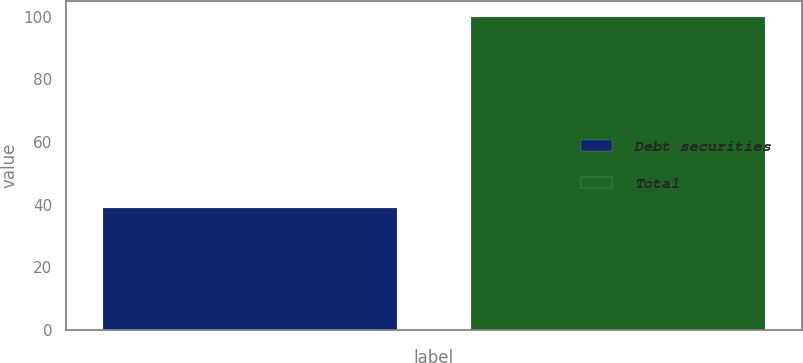Convert chart to OTSL. <chart><loc_0><loc_0><loc_500><loc_500><bar_chart><fcel>Debt securities<fcel>Total<nl><fcel>39<fcel>100<nl></chart> 